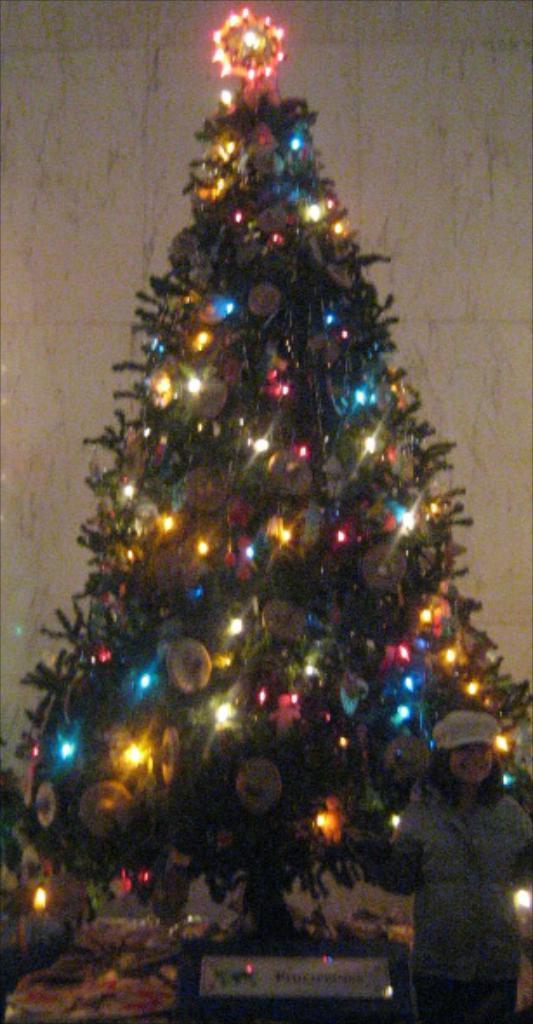How would you summarize this image in a sentence or two? In this image I can see a christmas tree which is green in color. To the tree I can see few decorative items and few lights. I can see a person standing in front of the tree and a wall behind the tree. 